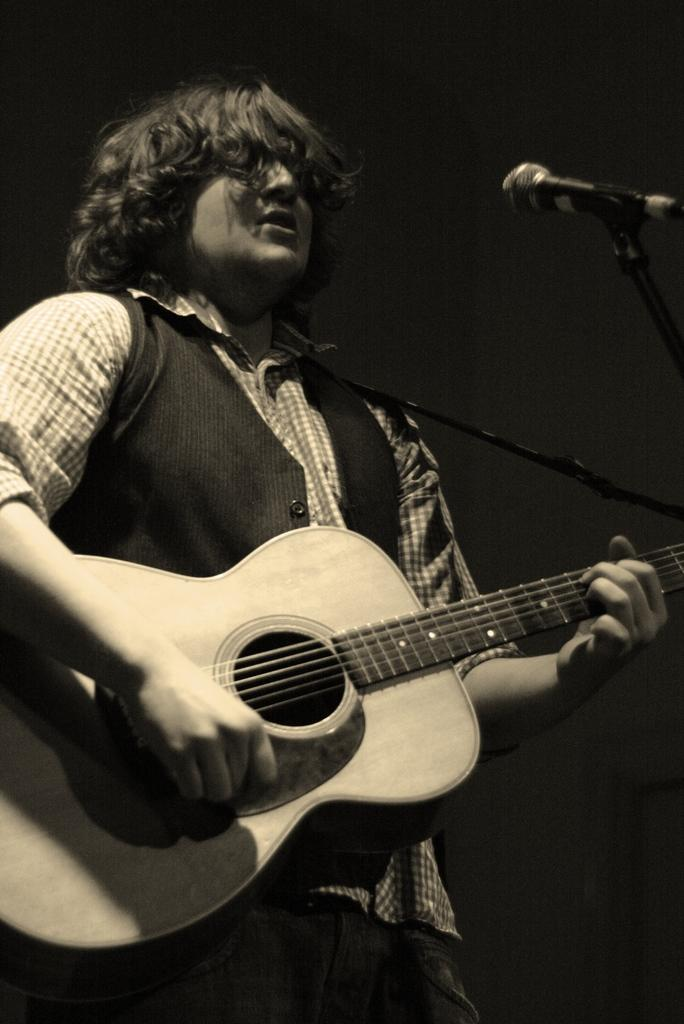What is the man in the image doing? The man is playing a guitar. What object is in front of the man? There is a microphone in front of the man. What is the size of the banana on the man's head in the image? There is: There is no banana present on the man's head in the image. 